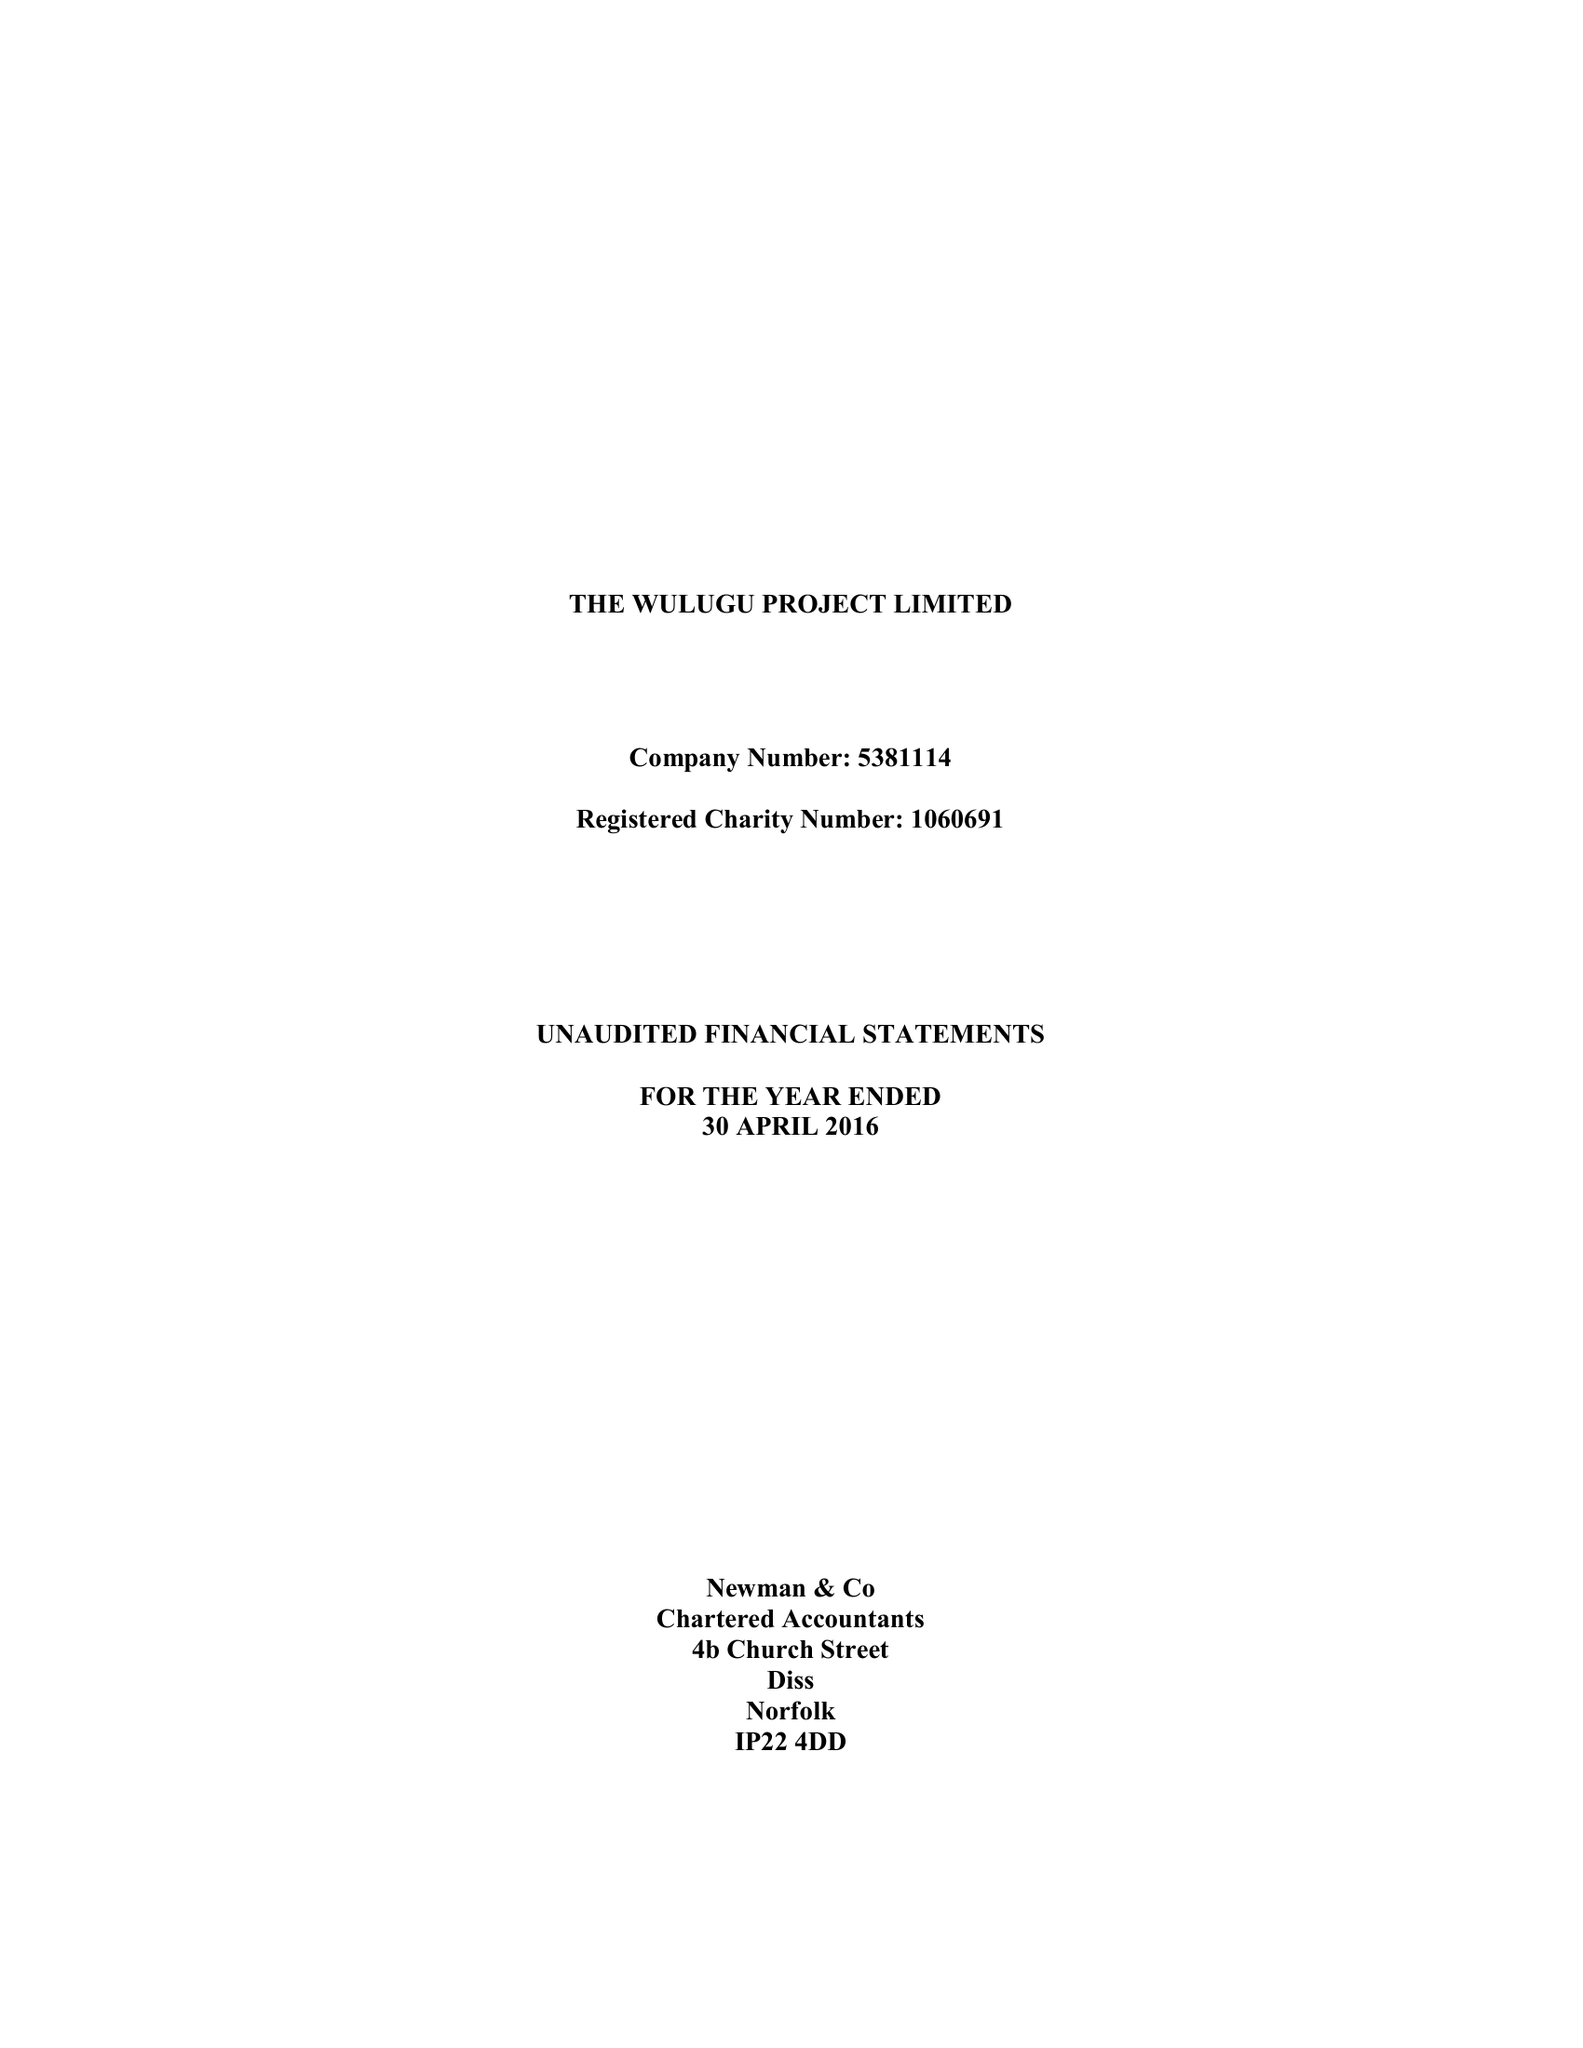What is the value for the income_annually_in_british_pounds?
Answer the question using a single word or phrase. 98944.00 